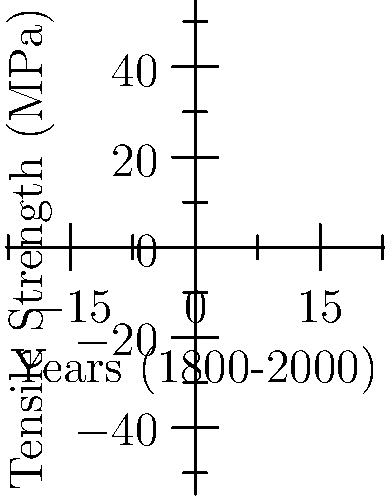Based on the graph showing the tensile strength of canvas materials used in American and Italian paintings from 1800 to 2000, what artistic or political factors might explain the difference in trends between the two countries' canvas materials? To answer this question, we need to analyze the graph and consider historical and artistic contexts:

1. Observe the trends:
   - Italian canvas (blue line): starts higher but increases more slowly
   - American canvas (red line): starts lower but increases more rapidly

2. Consider the historical context:
   - Italy: long-established artistic tradition, possibly using traditional materials
   - America: younger artistic tradition, potentially more open to innovation

3. Analyze potential factors:
   a) Artistic movements:
      - Italy: Renaissance influence, emphasis on traditional techniques
      - America: Abstract Expressionism, push for new materials and methods

   b) Industrial development:
      - America's rapid industrialization may have led to quicker adoption of new canvas materials

   c) Political climate:
      - Italy: periods of political instability might have affected artistic innovation
      - America: emphasis on progress and innovation in the 20th century

4. Economic factors:
   - Availability and cost of materials in each country
   - Trade policies affecting import/export of artistic supplies

5. Conservation practices:
   - Different approaches to art preservation may have influenced material choices

The answer should reflect an understanding of these factors without taking a political stance, focusing on the interplay between artistic traditions, technological advancements, and historical contexts in both countries.
Answer: Differing artistic traditions, industrial development rates, and attitudes towards innovation in art materials. 